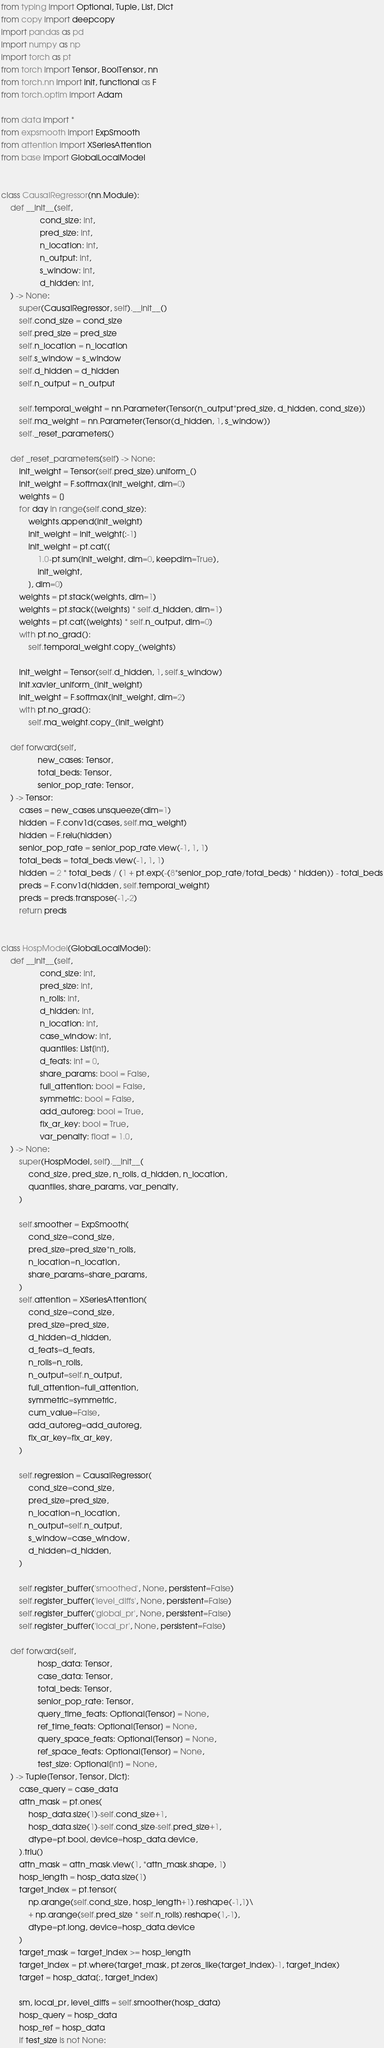Convert code to text. <code><loc_0><loc_0><loc_500><loc_500><_Python_>from typing import Optional, Tuple, List, Dict
from copy import deepcopy
import pandas as pd
import numpy as np
import torch as pt
from torch import Tensor, BoolTensor, nn
from torch.nn import init, functional as F
from torch.optim import Adam

from data import *
from expsmooth import ExpSmooth
from attention import XSeriesAttention
from base import GlobalLocalModel


class CausalRegressor(nn.Module):
    def __init__(self, 
                 cond_size: int,
                 pred_size: int,
                 n_location: int,
                 n_output: int,
                 s_window: int,
                 d_hidden: int,
    ) -> None:
        super(CausalRegressor, self).__init__()
        self.cond_size = cond_size
        self.pred_size = pred_size
        self.n_location = n_location
        self.s_window = s_window
        self.d_hidden = d_hidden
        self.n_output = n_output
        
        self.temporal_weight = nn.Parameter(Tensor(n_output*pred_size, d_hidden, cond_size))
        self.ma_weight = nn.Parameter(Tensor(d_hidden, 1, s_window))
        self._reset_parameters()
        
    def _reset_parameters(self) -> None:
        init_weight = Tensor(self.pred_size).uniform_()
        init_weight = F.softmax(init_weight, dim=0)
        weights = []
        for day in range(self.cond_size):
            weights.append(init_weight)
            init_weight = init_weight[:-1]
            init_weight = pt.cat([
                1.0-pt.sum(init_weight, dim=0, keepdim=True), 
                init_weight,
            ], dim=0)
        weights = pt.stack(weights, dim=1)
        weights = pt.stack([weights] * self.d_hidden, dim=1)
        weights = pt.cat([weights] * self.n_output, dim=0)
        with pt.no_grad():
            self.temporal_weight.copy_(weights)
        
        init_weight = Tensor(self.d_hidden, 1, self.s_window)
        init.xavier_uniform_(init_weight)
        init_weight = F.softmax(init_weight, dim=2)
        with pt.no_grad():
            self.ma_weight.copy_(init_weight)

    def forward(self,
                new_cases: Tensor,
                total_beds: Tensor,
                senior_pop_rate: Tensor,
    ) -> Tensor:
        cases = new_cases.unsqueeze(dim=1)
        hidden = F.conv1d(cases, self.ma_weight)
        hidden = F.relu(hidden)
        senior_pop_rate = senior_pop_rate.view(-1, 1, 1)
        total_beds = total_beds.view(-1, 1, 1)
        hidden = 2 * total_beds / (1 + pt.exp(-(8*senior_pop_rate/total_beds) * hidden)) - total_beds
        preds = F.conv1d(hidden, self.temporal_weight)
        preds = preds.transpose(-1,-2)
        return preds


class HospModel(GlobalLocalModel):
    def __init__(self,
                 cond_size: int,
                 pred_size: int,
                 n_rolls: int,
                 d_hidden: int,
                 n_location: int,
                 case_window: int,
                 quantiles: List[int],
                 d_feats: int = 0,
                 share_params: bool = False,
                 full_attention: bool = False,
                 symmetric: bool = False,
                 add_autoreg: bool = True,
                 fix_ar_key: bool = True,
                 var_penalty: float = 1.0,
    ) -> None:
        super(HospModel, self).__init__(
            cond_size, pred_size, n_rolls, d_hidden, n_location,
            quantiles, share_params, var_penalty,
        )
        
        self.smoother = ExpSmooth(
            cond_size=cond_size, 
            pred_size=pred_size*n_rolls, 
            n_location=n_location,
            share_params=share_params,
        )
        self.attention = XSeriesAttention(
            cond_size=cond_size,
            pred_size=pred_size,
            d_hidden=d_hidden,
            d_feats=d_feats,
            n_rolls=n_rolls,
            n_output=self.n_output,
            full_attention=full_attention,
            symmetric=symmetric,
            cum_value=False,
            add_autoreg=add_autoreg,
            fix_ar_key=fix_ar_key,
        )
        
        self.regression = CausalRegressor(
            cond_size=cond_size,
            pred_size=pred_size,
            n_location=n_location,
            n_output=self.n_output,
            s_window=case_window,
            d_hidden=d_hidden,
        )

        self.register_buffer('smoothed', None, persistent=False)
        self.register_buffer('level_diffs', None, persistent=False)
        self.register_buffer('global_pr', None, persistent=False)
        self.register_buffer('local_pr', None, persistent=False)

    def forward(self, 
                hosp_data: Tensor,
                case_data: Tensor,
                total_beds: Tensor,
                senior_pop_rate: Tensor,
                query_time_feats: Optional[Tensor] = None,
                ref_time_feats: Optional[Tensor] = None,
                query_space_feats: Optional[Tensor] = None,
                ref_space_feats: Optional[Tensor] = None,
                test_size: Optional[int] = None,
    ) -> Tuple[Tensor, Tensor, Dict]:
        case_query = case_data
        attn_mask = pt.ones(
            hosp_data.size(1)-self.cond_size+1,
            hosp_data.size(1)-self.cond_size-self.pred_size+1,
            dtype=pt.bool, device=hosp_data.device,
        ).triu()
        attn_mask = attn_mask.view(1, *attn_mask.shape, 1)
        hosp_length = hosp_data.size(1)
        target_index = pt.tensor(
            np.arange(self.cond_size, hosp_length+1).reshape(-1,1)\
            + np.arange(self.pred_size * self.n_rolls).reshape(1,-1),
            dtype=pt.long, device=hosp_data.device
        )
        target_mask = target_index >= hosp_length
        target_index = pt.where(target_mask, pt.zeros_like(target_index)-1, target_index)
        target = hosp_data[:, target_index]
        
        sm, local_pr, level_diffs = self.smoother(hosp_data)
        hosp_query = hosp_data
        hosp_ref = hosp_data
        if test_size is not None:</code> 